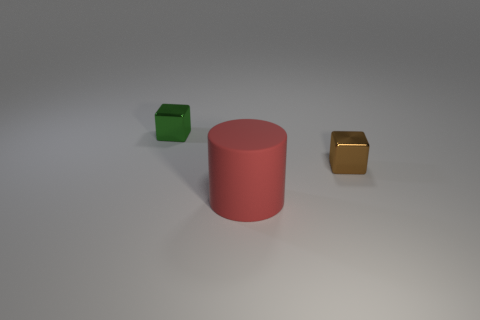Is there any texture or pattern on the surface where the objects are placed? From this view, the surface appears smooth and lacks any distinct texture or pattern. It's a plain, homogenous area that puts the focus on the objects themselves without any distractions. 